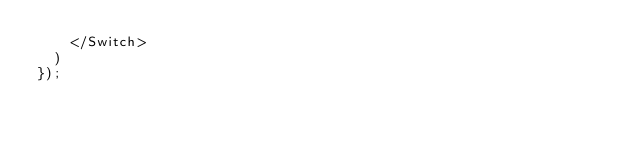Convert code to text. <code><loc_0><loc_0><loc_500><loc_500><_TypeScript_>    </Switch>
  )
});
</code> 